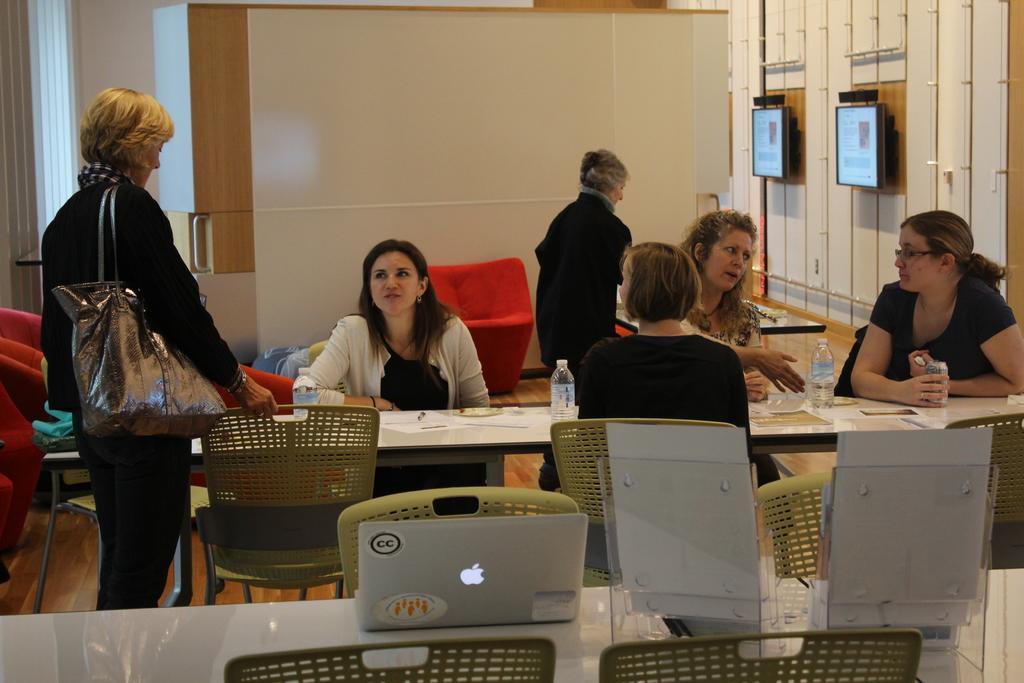How would you summarize this image in a sentence or two? This picture is clicked in the room. Four women are sitting on chair on either side of the table. On table, we see paper, pen, plate and water bottle are placed. Behind them, we see a red chair and a white wall and on right corner of the picture, we see two televisions. Woman on left corner is standing and she is wearing handbag. 